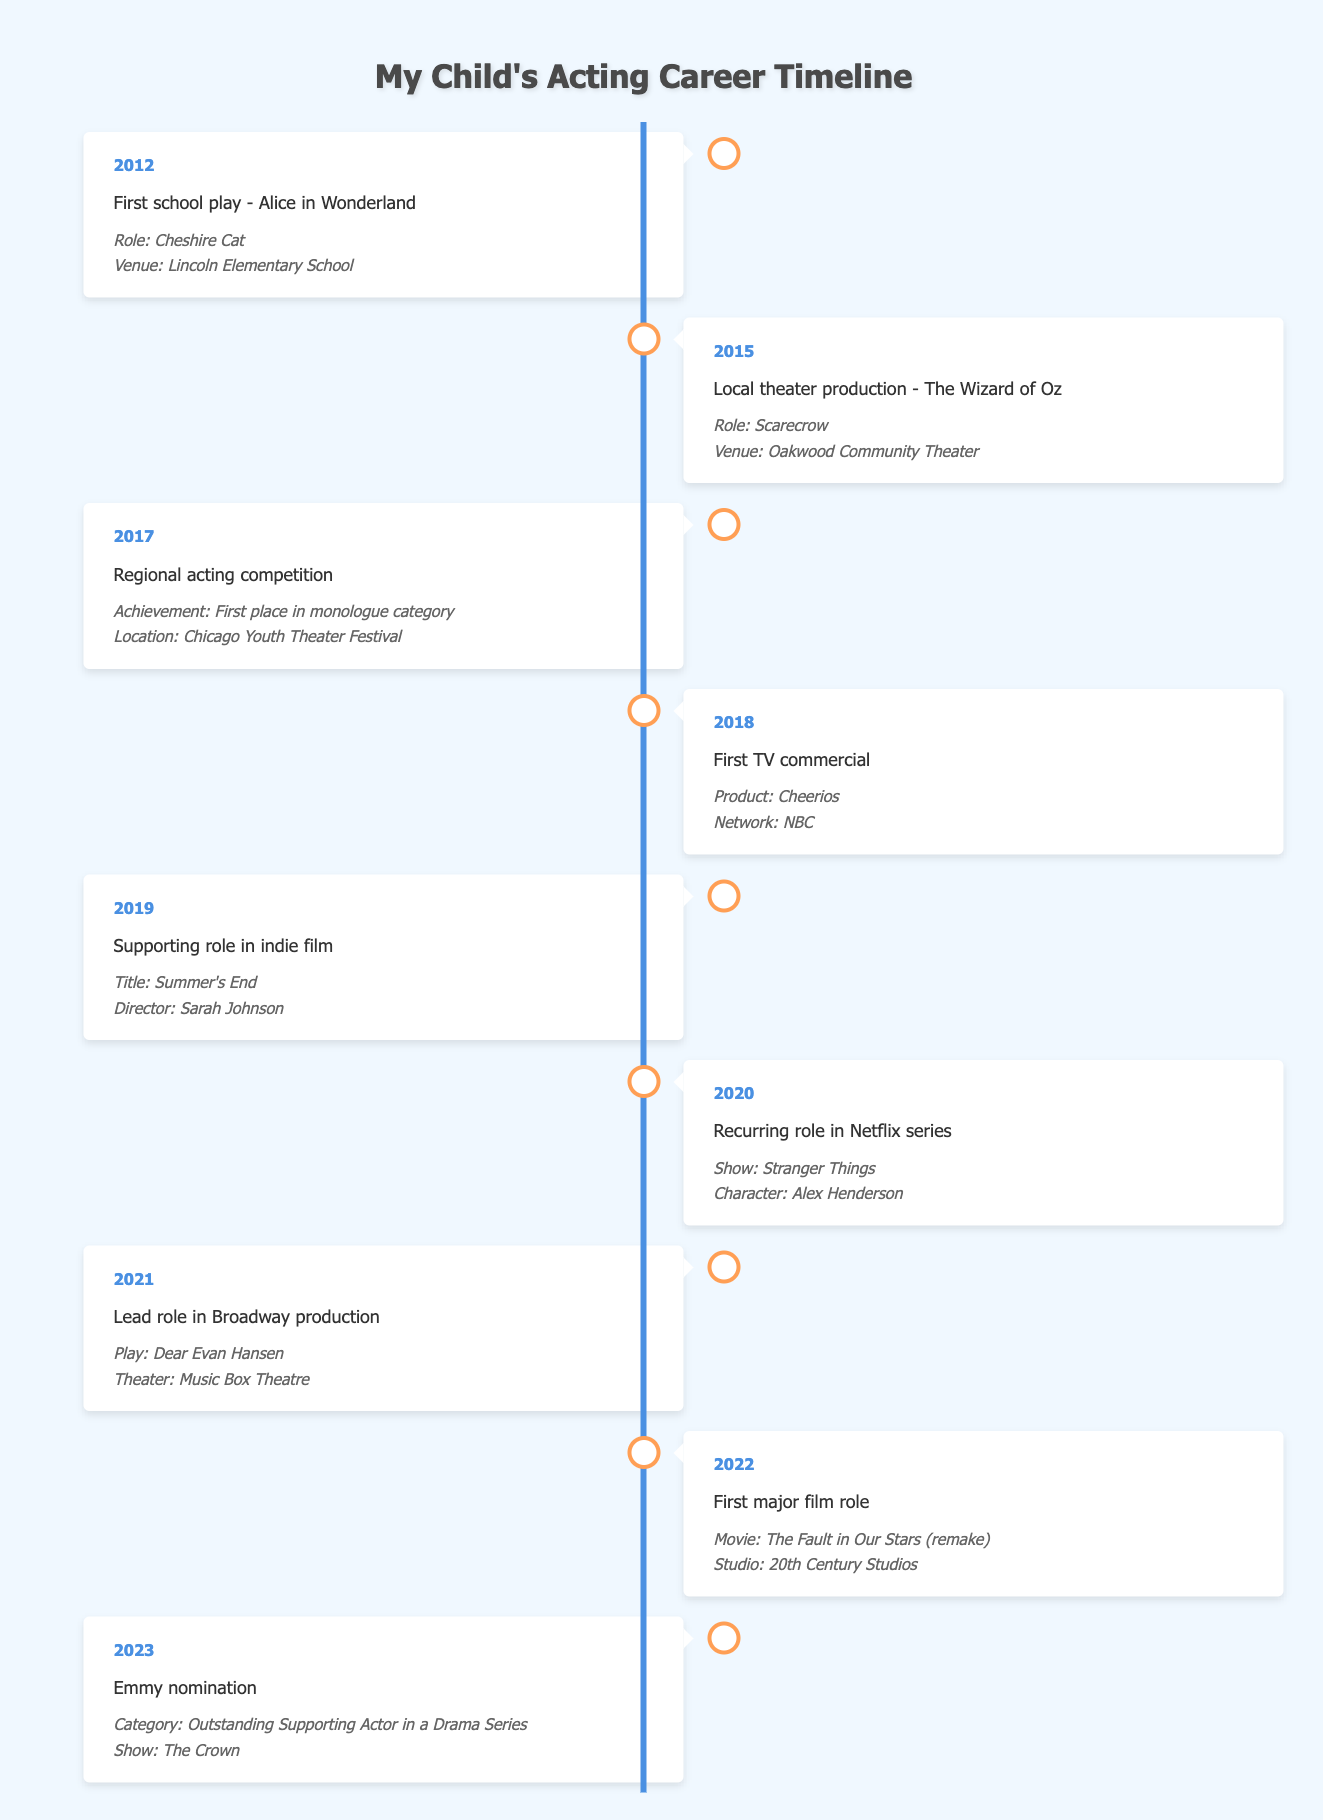What was my child's first acting role? According to the table, the first acting role was in 2012 as the Cheshire Cat in the school play "Alice in Wonderland."
Answer: Cheshire Cat In which year did my child compete in a regional acting competition? The table indicates that my child participated in a regional acting competition in 2017, where they won first place in the monologue category.
Answer: 2017 How many significant milestones occurred before 2020? Looking at the timeline, there are five significant milestones (2012, 2015, 2017, 2018, and 2019) before the year 2020.
Answer: 5 Did my child have any roles in film production in 2022? Yes, in 2022, my child had their first major film role in the remake of "The Fault in Our Stars".
Answer: Yes What percentage of milestones involved a performance role compared to total milestones? There are eight milestones listed, of which six involve a performance role (first play, theater production, supporting role, recurring role, lead role, major film role). To calculate the percentage, divide 6 by 8, which equals 0.75 or 75%.
Answer: 75% What character did my child portray in "Stranger Things"? The table states my child's character in "Stranger Things" was Alex Henderson during their recurring role in 2020.
Answer: Alex Henderson Which year marked the most recent achievement, and what was it? The most recent achievement on the timeline is from 2023, where my child received an Emmy nomination for Outstanding Supporting Actor in a Drama Series for "The Crown."
Answer: 2023, Emmy nomination How did my child's achievements in film compare to those in theater by 2021? By 2021, my child's achievements in theater include their lead role in "Dear Evan Hansen" and earlier performances, while in film, they have a supporting role in "Summer's End" before the major film role in 2022. This indicates theater was more prominent up to 2021, with only one film achievement compared to the theater milestones.
Answer: Theater was more prominent 